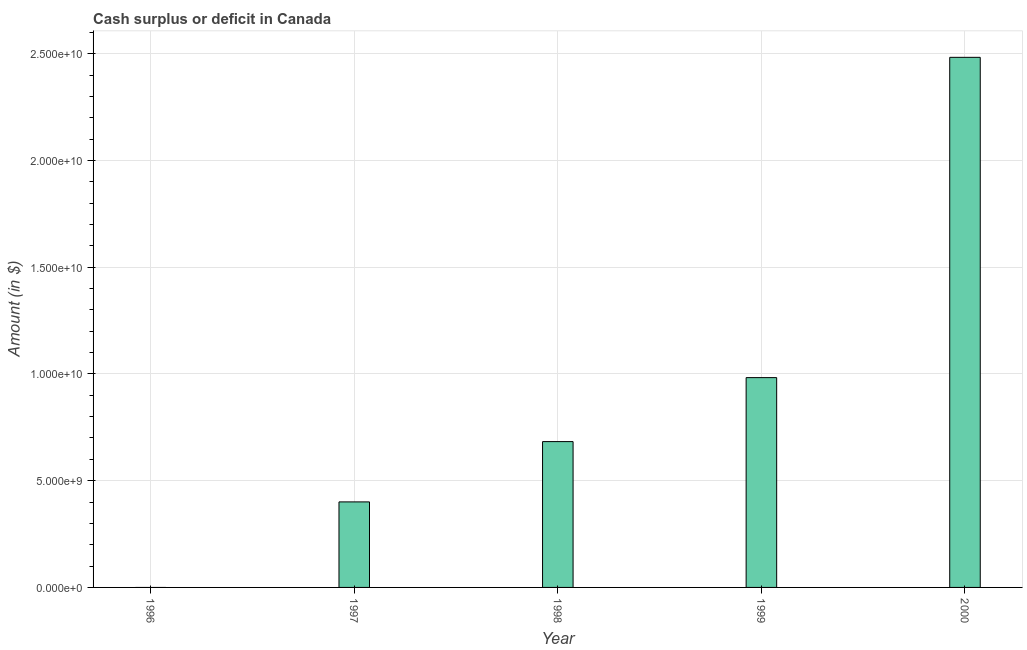Does the graph contain any zero values?
Keep it short and to the point. Yes. What is the title of the graph?
Keep it short and to the point. Cash surplus or deficit in Canada. What is the label or title of the X-axis?
Provide a succinct answer. Year. What is the label or title of the Y-axis?
Give a very brief answer. Amount (in $). What is the cash surplus or deficit in 1997?
Make the answer very short. 4.01e+09. Across all years, what is the maximum cash surplus or deficit?
Offer a very short reply. 2.48e+1. Across all years, what is the minimum cash surplus or deficit?
Offer a very short reply. 0. What is the sum of the cash surplus or deficit?
Your response must be concise. 4.55e+1. What is the difference between the cash surplus or deficit in 1998 and 2000?
Give a very brief answer. -1.80e+1. What is the average cash surplus or deficit per year?
Your response must be concise. 9.10e+09. What is the median cash surplus or deficit?
Give a very brief answer. 6.83e+09. What is the ratio of the cash surplus or deficit in 1998 to that in 1999?
Give a very brief answer. 0.69. Is the cash surplus or deficit in 1998 less than that in 2000?
Provide a short and direct response. Yes. What is the difference between the highest and the second highest cash surplus or deficit?
Provide a succinct answer. 1.50e+1. What is the difference between the highest and the lowest cash surplus or deficit?
Provide a short and direct response. 2.48e+1. In how many years, is the cash surplus or deficit greater than the average cash surplus or deficit taken over all years?
Provide a short and direct response. 2. How many bars are there?
Offer a very short reply. 4. How many years are there in the graph?
Offer a very short reply. 5. What is the Amount (in $) of 1996?
Keep it short and to the point. 0. What is the Amount (in $) of 1997?
Keep it short and to the point. 4.01e+09. What is the Amount (in $) in 1998?
Offer a terse response. 6.83e+09. What is the Amount (in $) of 1999?
Keep it short and to the point. 9.83e+09. What is the Amount (in $) in 2000?
Your answer should be very brief. 2.48e+1. What is the difference between the Amount (in $) in 1997 and 1998?
Keep it short and to the point. -2.82e+09. What is the difference between the Amount (in $) in 1997 and 1999?
Provide a succinct answer. -5.82e+09. What is the difference between the Amount (in $) in 1997 and 2000?
Make the answer very short. -2.08e+1. What is the difference between the Amount (in $) in 1998 and 1999?
Offer a very short reply. -3.00e+09. What is the difference between the Amount (in $) in 1998 and 2000?
Offer a very short reply. -1.80e+1. What is the difference between the Amount (in $) in 1999 and 2000?
Offer a very short reply. -1.50e+1. What is the ratio of the Amount (in $) in 1997 to that in 1998?
Provide a succinct answer. 0.59. What is the ratio of the Amount (in $) in 1997 to that in 1999?
Your answer should be compact. 0.41. What is the ratio of the Amount (in $) in 1997 to that in 2000?
Give a very brief answer. 0.16. What is the ratio of the Amount (in $) in 1998 to that in 1999?
Provide a succinct answer. 0.69. What is the ratio of the Amount (in $) in 1998 to that in 2000?
Your answer should be compact. 0.28. What is the ratio of the Amount (in $) in 1999 to that in 2000?
Your answer should be very brief. 0.4. 